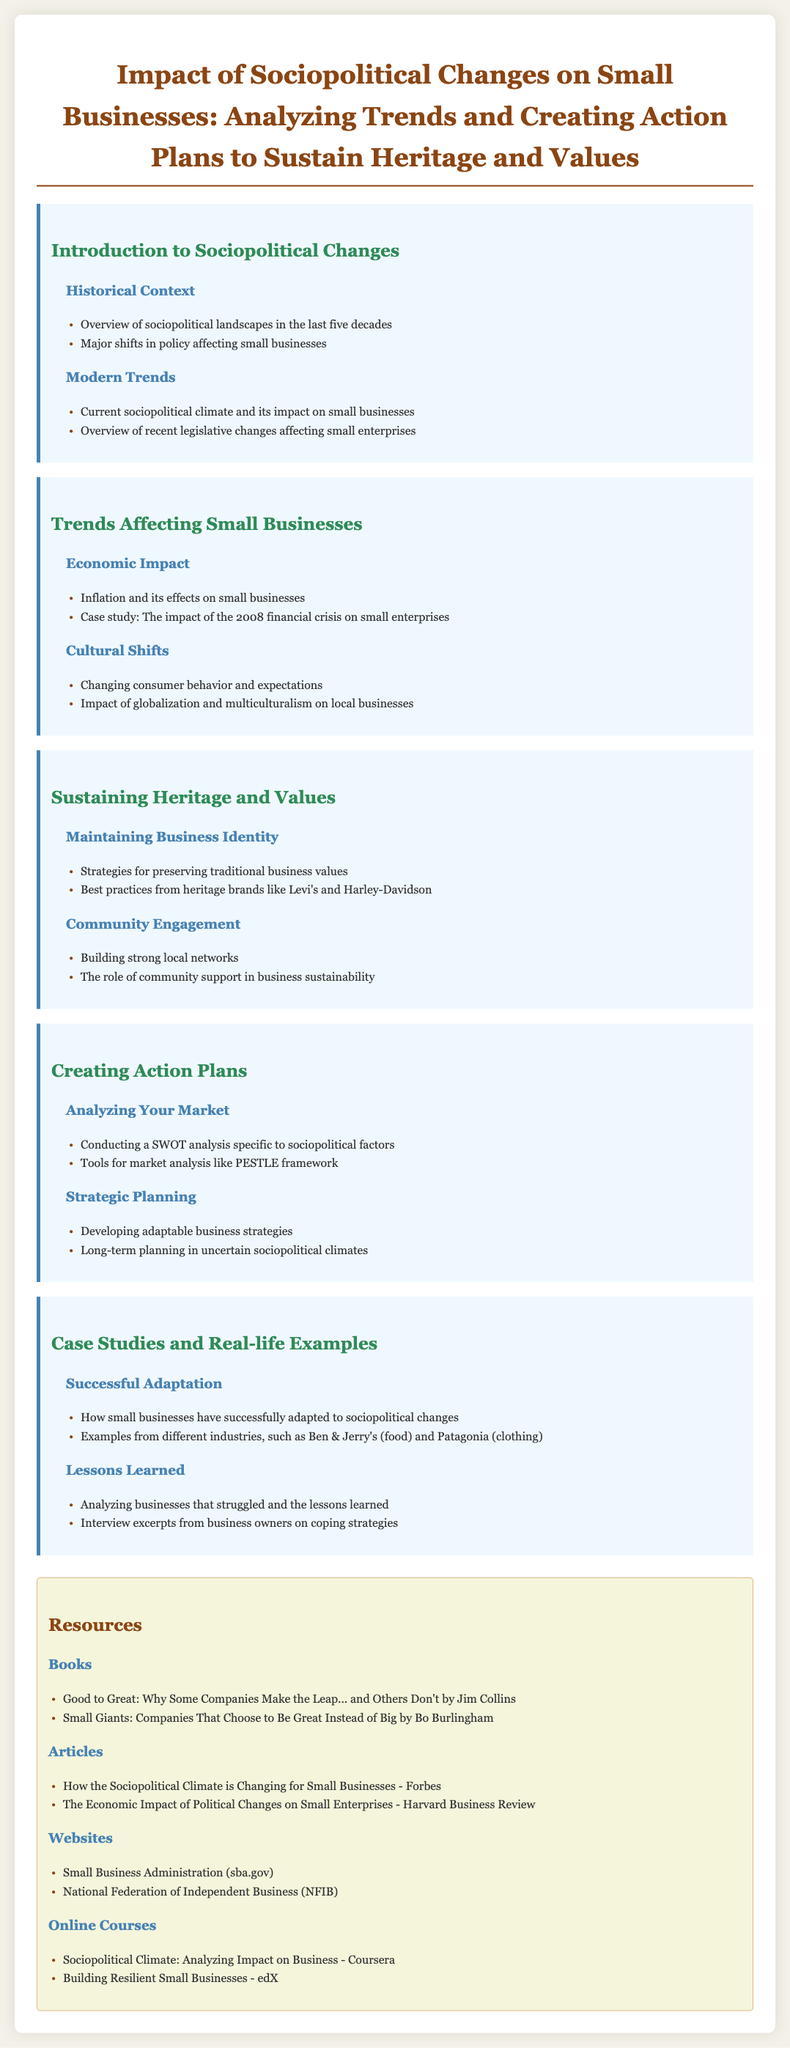what is the title of the syllabus? The title is the heading of the document, which outlines its main focus.
Answer: Impact of Sociopolitical Changes on Small Businesses: Analyzing Trends and Creating Action Plans to Sustain Heritage and Values how many units are there in the syllabus? The document outlines multiple sections denoted as units, each covering specific topics.
Answer: 5 name one book listed in the resources section. The resources section includes a list of books that are relevant to the syllabus.
Answer: Good to Great: Why Some Companies Make the Leap... and Others Don't what is one cultural shift mentioned that affects small businesses? The document discusses various cultural shifts impacting small businesses under the Trends Affecting Small Businesses unit.
Answer: Changing consumer behavior and expectations which company is cited as an example of a heritage brand? The syllabus references specific companies known for their traditional values, which serve as case studies.
Answer: Levi's 